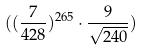Convert formula to latex. <formula><loc_0><loc_0><loc_500><loc_500>( ( \frac { 7 } { 4 2 8 } ) ^ { 2 6 5 } \cdot \frac { 9 } { \sqrt { 2 4 0 } } )</formula> 